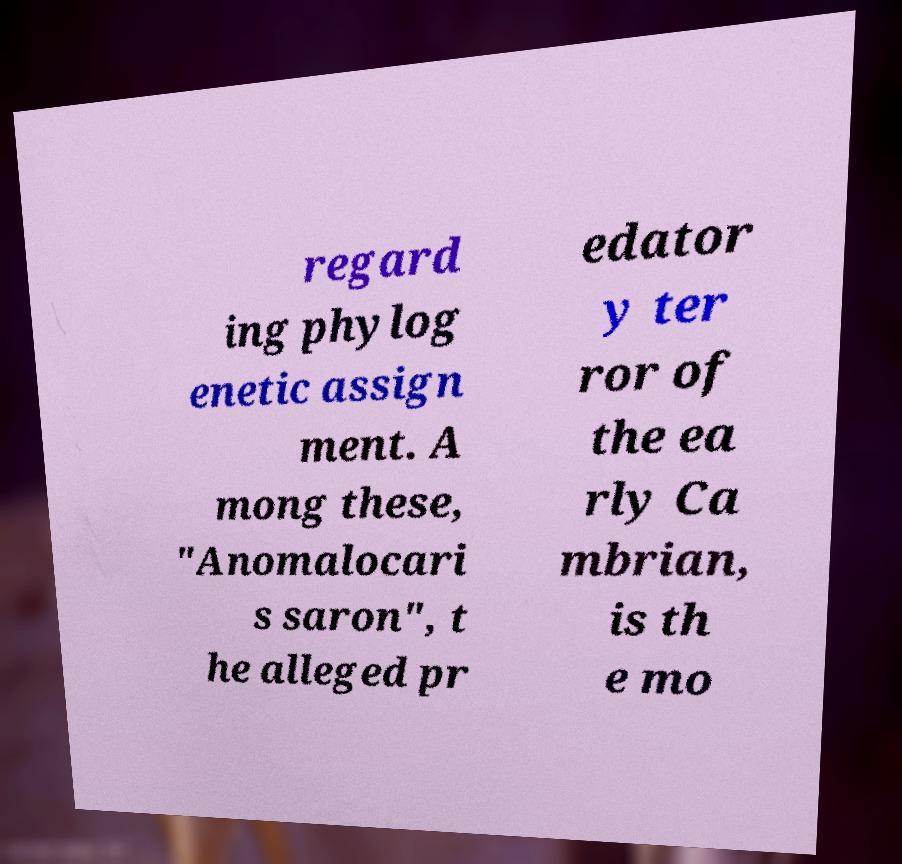Can you read and provide the text displayed in the image?This photo seems to have some interesting text. Can you extract and type it out for me? regard ing phylog enetic assign ment. A mong these, "Anomalocari s saron", t he alleged pr edator y ter ror of the ea rly Ca mbrian, is th e mo 